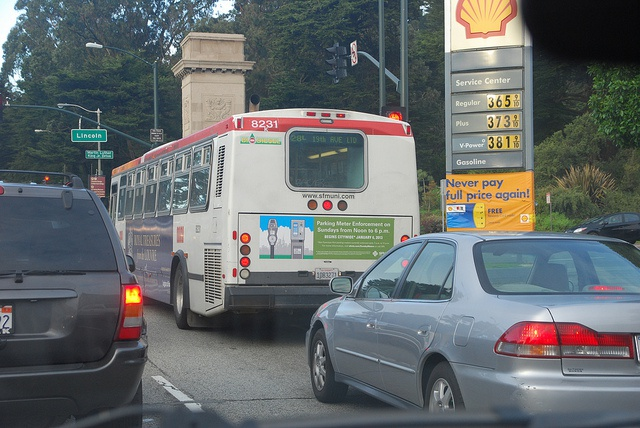Describe the objects in this image and their specific colors. I can see car in lightblue, gray, and darkgray tones, bus in lightblue, lightgray, gray, darkgray, and black tones, car in lightblue, black, gray, and blue tones, car in lightblue, blue, and black tones, and traffic light in lightblue, blue, gray, and darkblue tones in this image. 